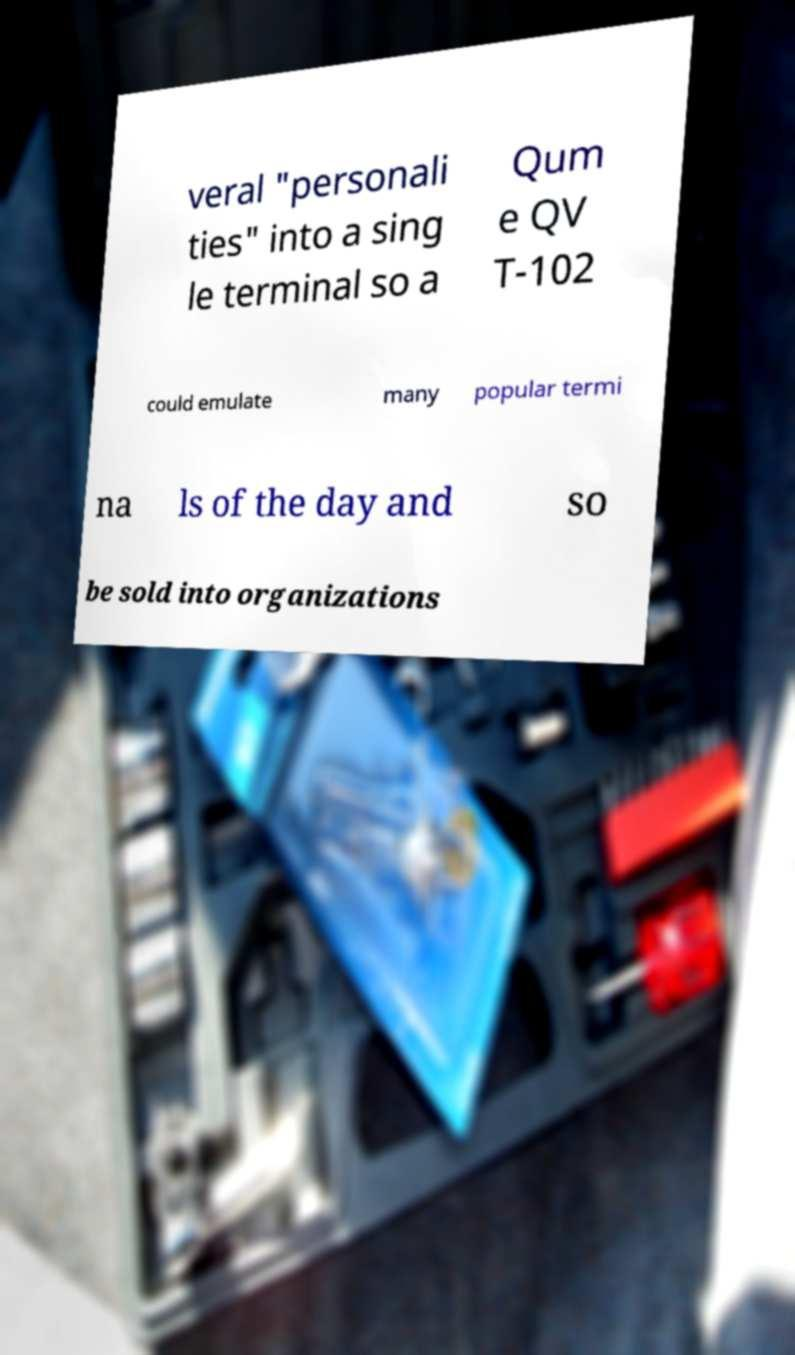I need the written content from this picture converted into text. Can you do that? veral "personali ties" into a sing le terminal so a Qum e QV T-102 could emulate many popular termi na ls of the day and so be sold into organizations 